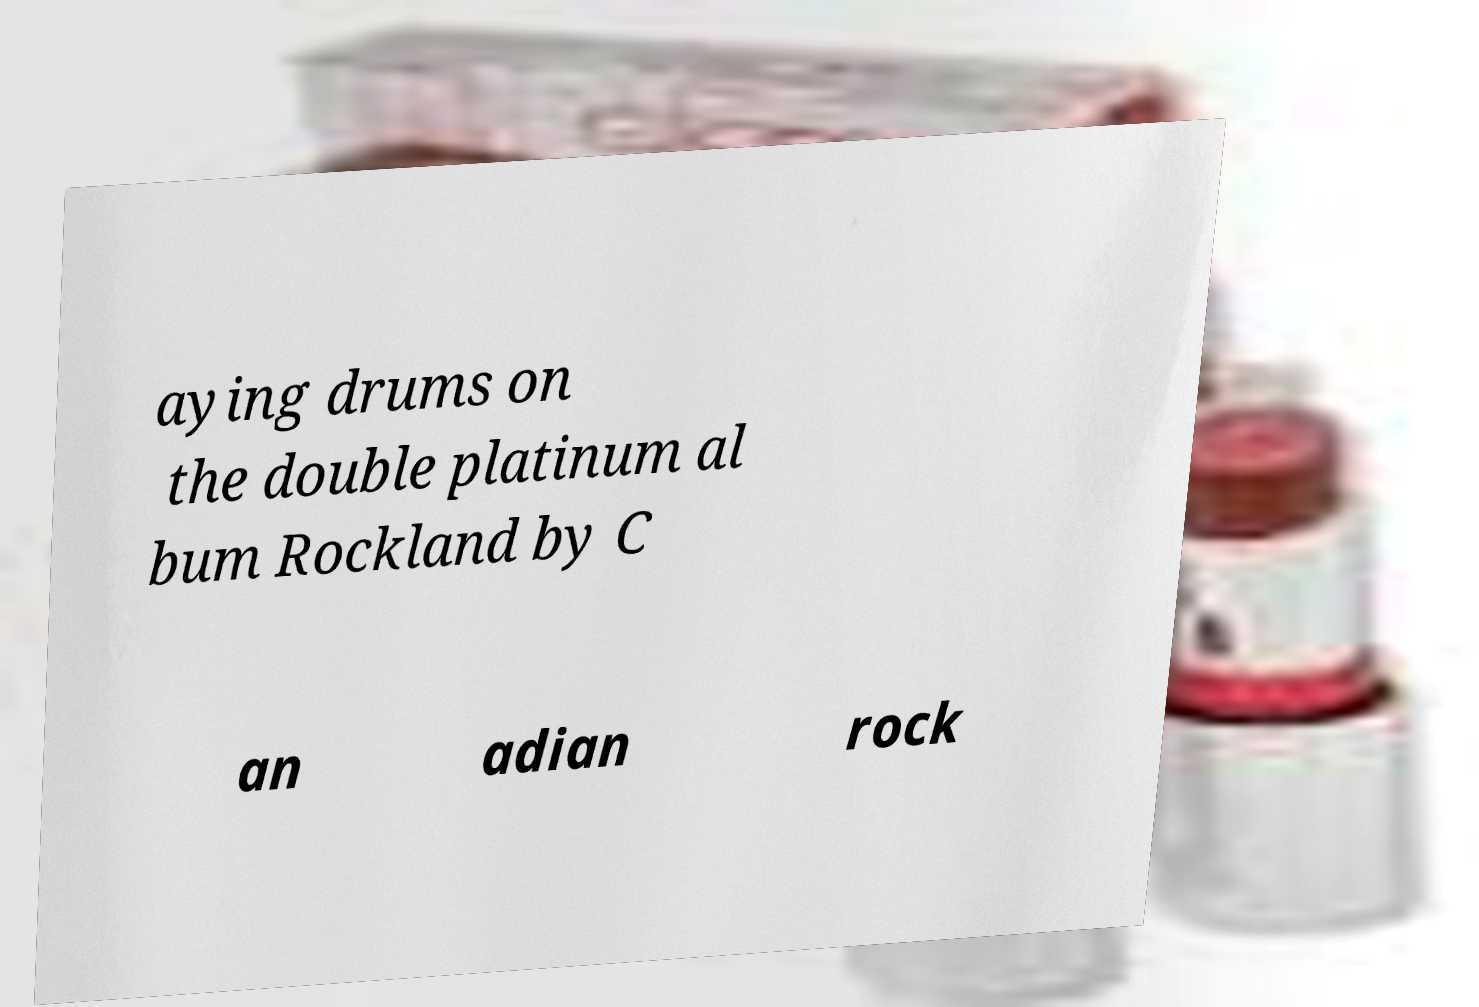I need the written content from this picture converted into text. Can you do that? aying drums on the double platinum al bum Rockland by C an adian rock 